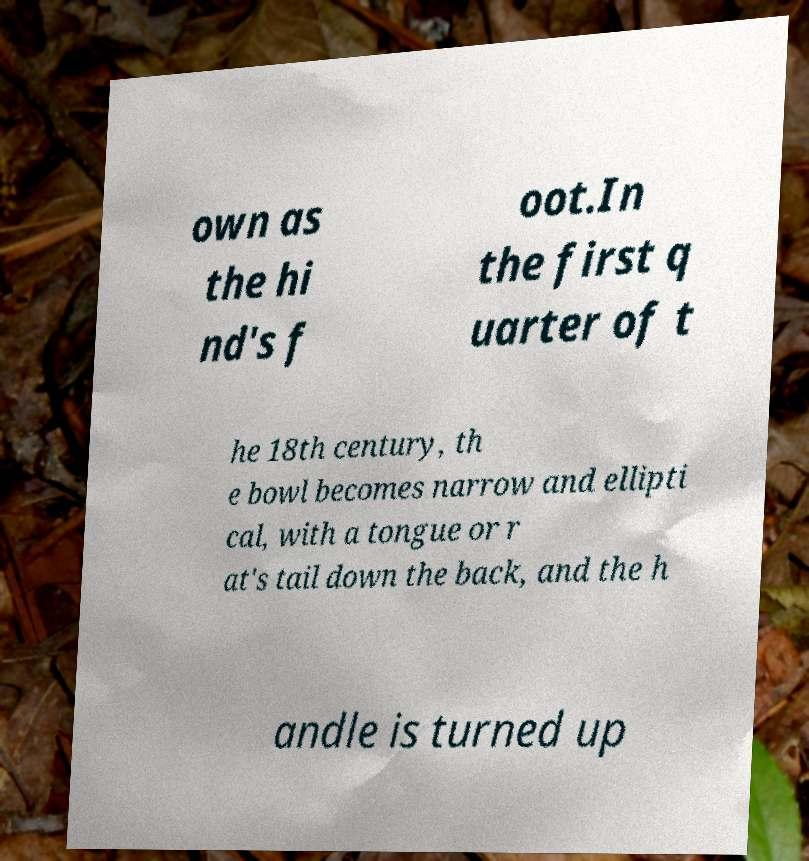Could you assist in decoding the text presented in this image and type it out clearly? own as the hi nd's f oot.In the first q uarter of t he 18th century, th e bowl becomes narrow and ellipti cal, with a tongue or r at's tail down the back, and the h andle is turned up 